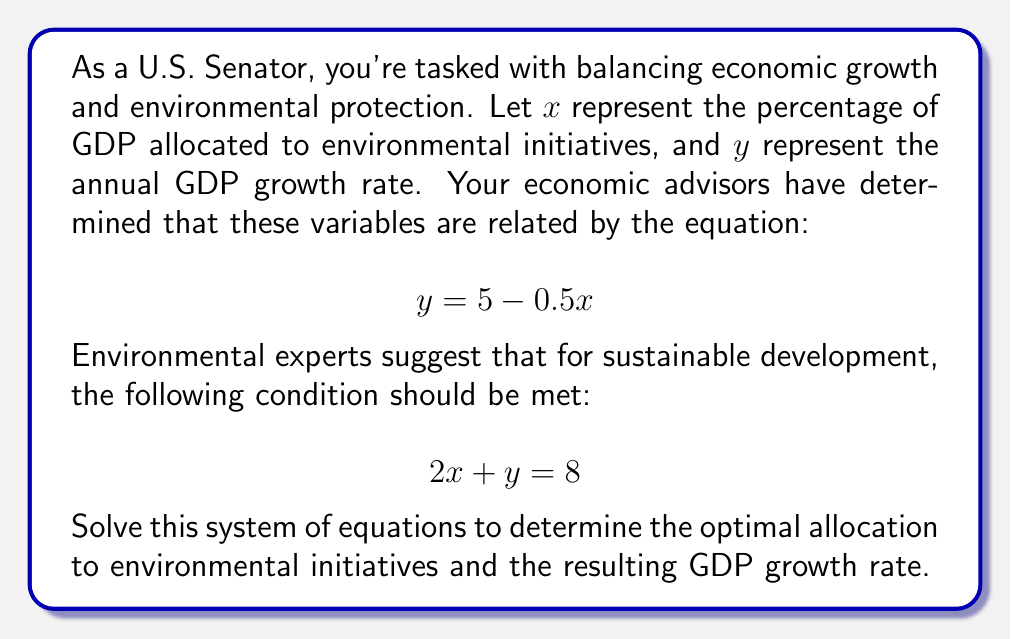Could you help me with this problem? To solve this system of equations, we'll use the substitution method:

1) We have two equations:
   $$y = 5 - 0.5x$$ (Equation 1)
   $$2x + y = 8$$ (Equation 2)

2) Substitute Equation 1 into Equation 2:
   $$2x + (5 - 0.5x) = 8$$

3) Simplify:
   $$2x + 5 - 0.5x = 8$$
   $$1.5x + 5 = 8$$

4) Subtract 5 from both sides:
   $$1.5x = 3$$

5) Divide both sides by 1.5:
   $$x = 2$$

6) Now that we know $x$, we can find $y$ using Equation 1:
   $$y = 5 - 0.5(2) = 5 - 1 = 4$$

Therefore, the optimal allocation to environmental initiatives ($x$) is 2% of GDP, and the resulting GDP growth rate ($y$) is 4%.
Answer: $x = 2$, $y = 4$ 